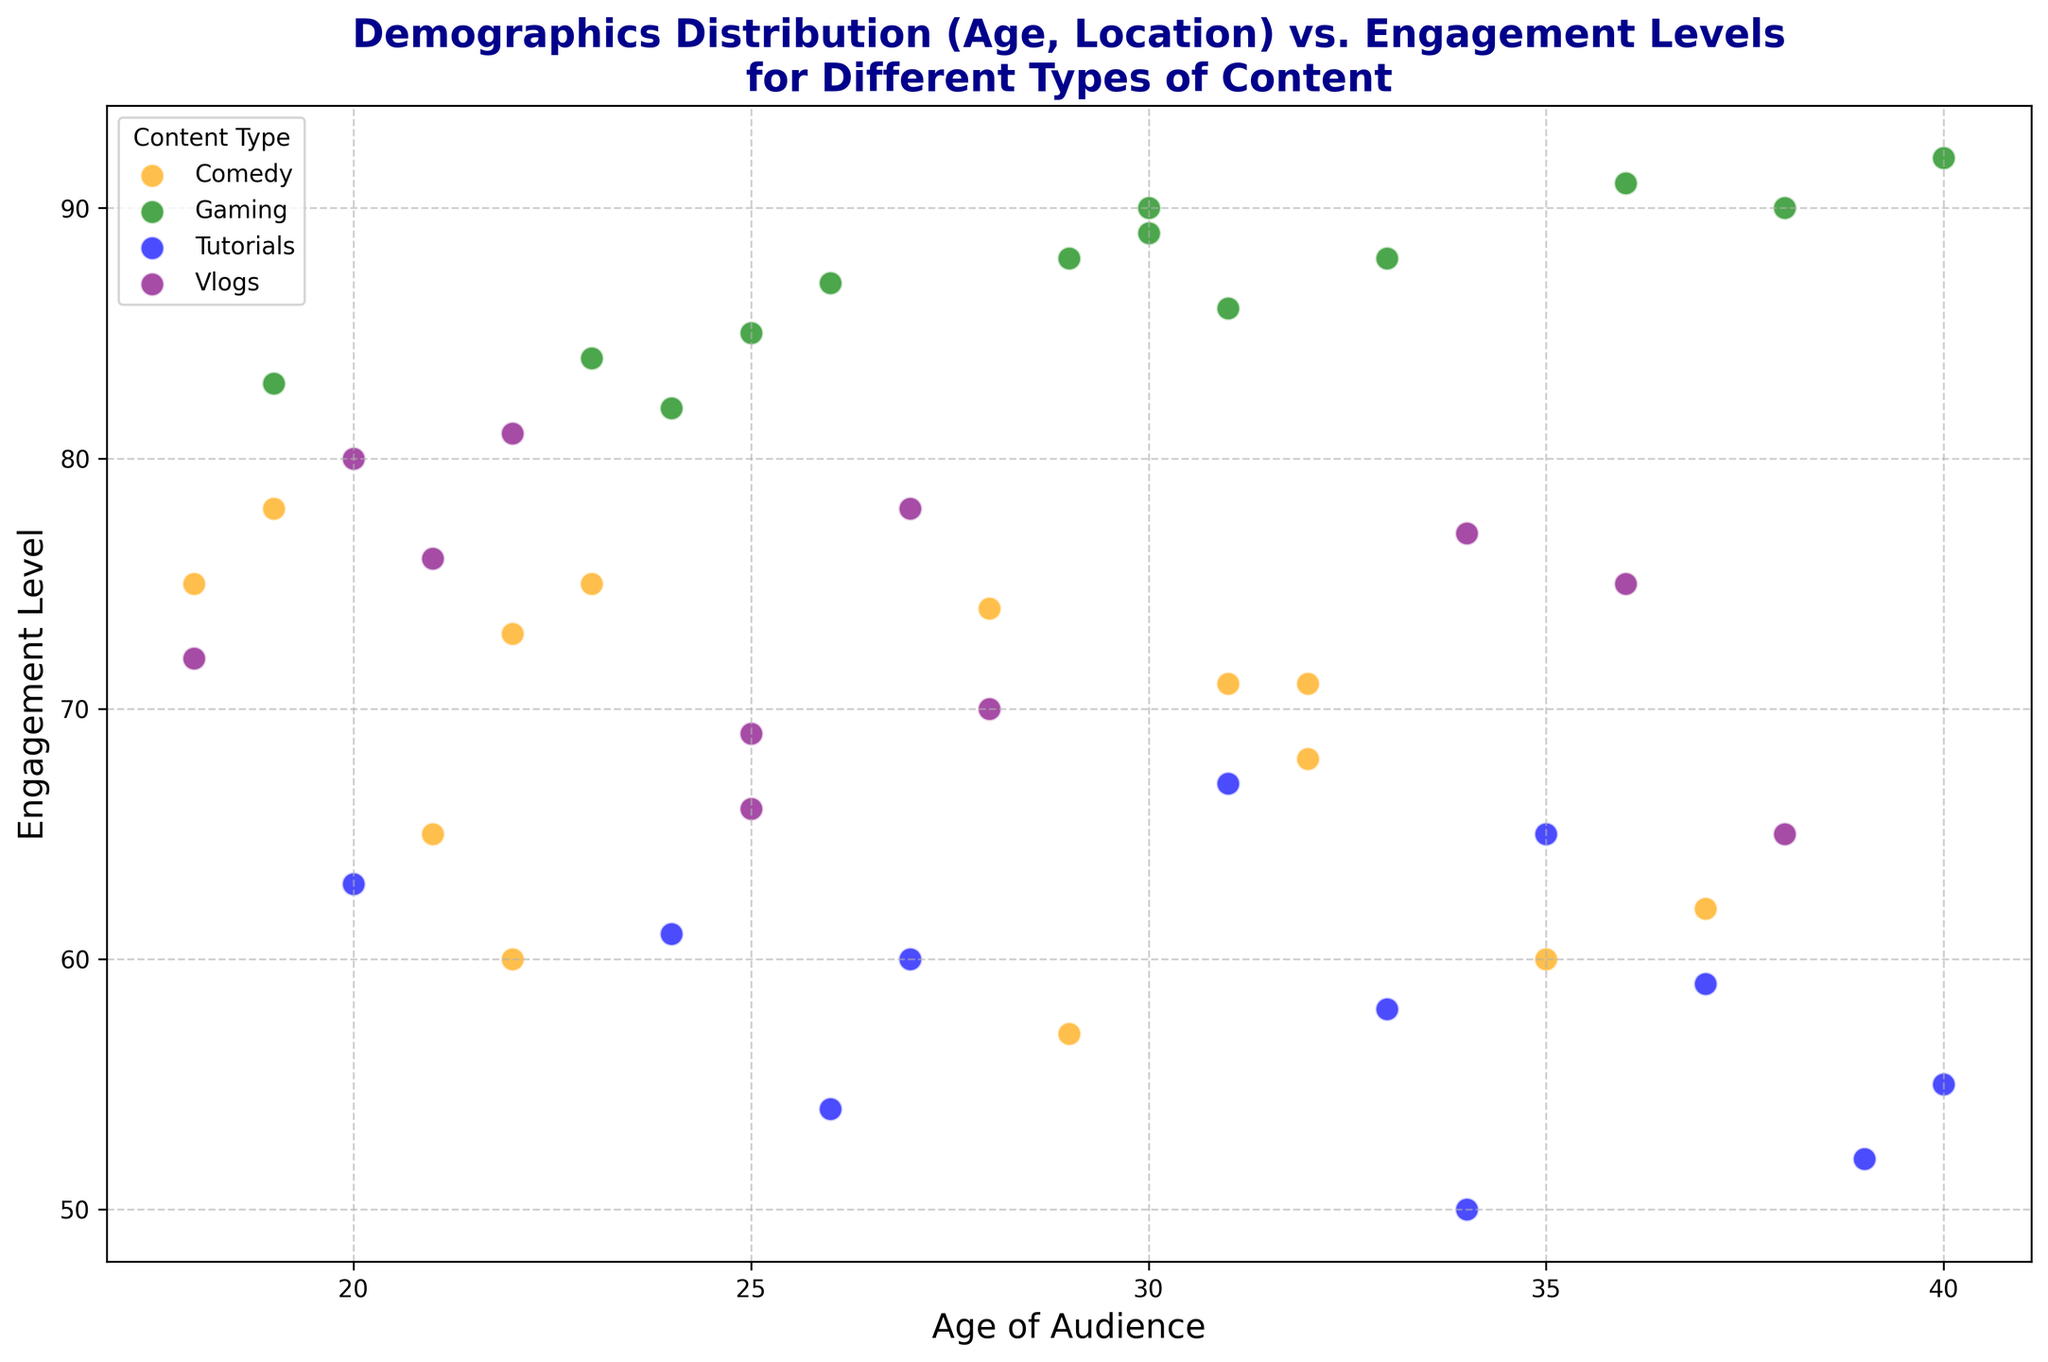Which content type has the highest engagement level? Look at the scatter plot and identify the content type that corresponds to the highest y-value (Engagement Level). The highest engagement level is 92, which corresponds to Gaming content.
Answer: Gaming Which age group engages the most with Comedy content? Find the data points representing Comedy content and identify the one with the highest y-value (Engagement Level). The highest engagement level for Comedy content is 78, associated with age 19.
Answer: Age 19 Among the audience aged between 20 and 30, which content type generally has higher engagement levels? Isolate the age range 20-30 in the scatter plot and compare the Engagement Levels for different content types. Gaming and Vlogs seem to have slightly higher engagement levels in this age group.
Answer: Gaming and Vlogs What is the average engagement level for Gaming content? Extract the Engagement Levels of Gaming content, sum them up, and then divide by the number of data points. The Engagement Levels for Gaming are 85, 90, 84, 88, 83, 89, 86, 91, and 88, which sum to 774. There are 9 data points, so the average is 774/9 ≈ 86.
Answer: 86 Is there a noticeable difference in engagement levels for Tutorials between different age groups? Look at the scatter plot for data points representing Tutorials and compare the Engagement Levels across different ages. The levels vary from 50 to 67, indicating some fluctuation but not a huge difference.
Answer: Yes, there is some variation What are the engagement levels for Vlogs at ages 20, 27, and 34? Identify the data points for Vlogs at ages 20, 27, and 34 and read their Engagement Levels. The levels are 80 (age 20), 78 (age 27), and 77 (age 34).
Answer: 80, 78, 77 Do audiences from the USA engage more with Comedy or Tutorials? Find data points representing Comedy and Tutorials content from the USA and compare their Engagement Levels. USA audience for Comedy: 75, 73, 78, 62, 71 and for Tutorials: 65, 63, 61, 58, 59. The average Engagement Level for Comedy is (75+73+78+62+71)/5 = 71.8 and for Tutorials is (65+63+61+58+59)/5 = 61.2. Comedy has higher engagement.
Answer: Comedy Which content type shows the most variation in engagement levels? Look at the range of Engagement Levels for each content type. Comedy ranges from 57 to 78, Gaming from 83 to 92, Tutorials from 50 to 67, and Vlogs from 65 to 80. Comedy and Vlogs show higher variation.
Answer: Comedy and Vlogs How does engagement with Vlogs differ between Canada and Australia? Find data points representing Vlogs content from Canada and Australia, then compare their Engagement Levels. Canada Vlogs: 72, 81; Australia Vlogs: 70, 75, 65. Canada's average is (72+81)/2 = 76.5 and Australia's average is (70+75+65)/3 ≈ 70.
Answer: Canada's audience engages more with Vlogs 